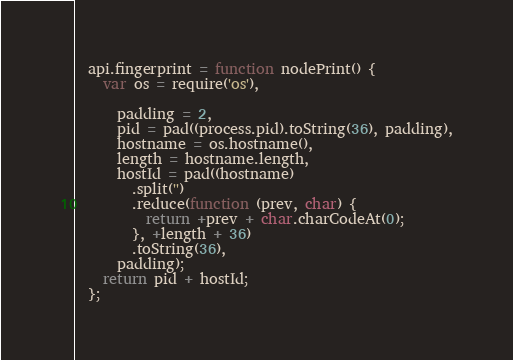<code> <loc_0><loc_0><loc_500><loc_500><_JavaScript_>  api.fingerprint = function nodePrint() {
    var os = require('os'),

      padding = 2,
      pid = pad((process.pid).toString(36), padding),
      hostname = os.hostname(),
      length = hostname.length,
      hostId = pad((hostname)
        .split('')
        .reduce(function (prev, char) {
          return +prev + char.charCodeAt(0);
        }, +length + 36)
        .toString(36),
      padding);
    return pid + hostId;
  };
</code> 